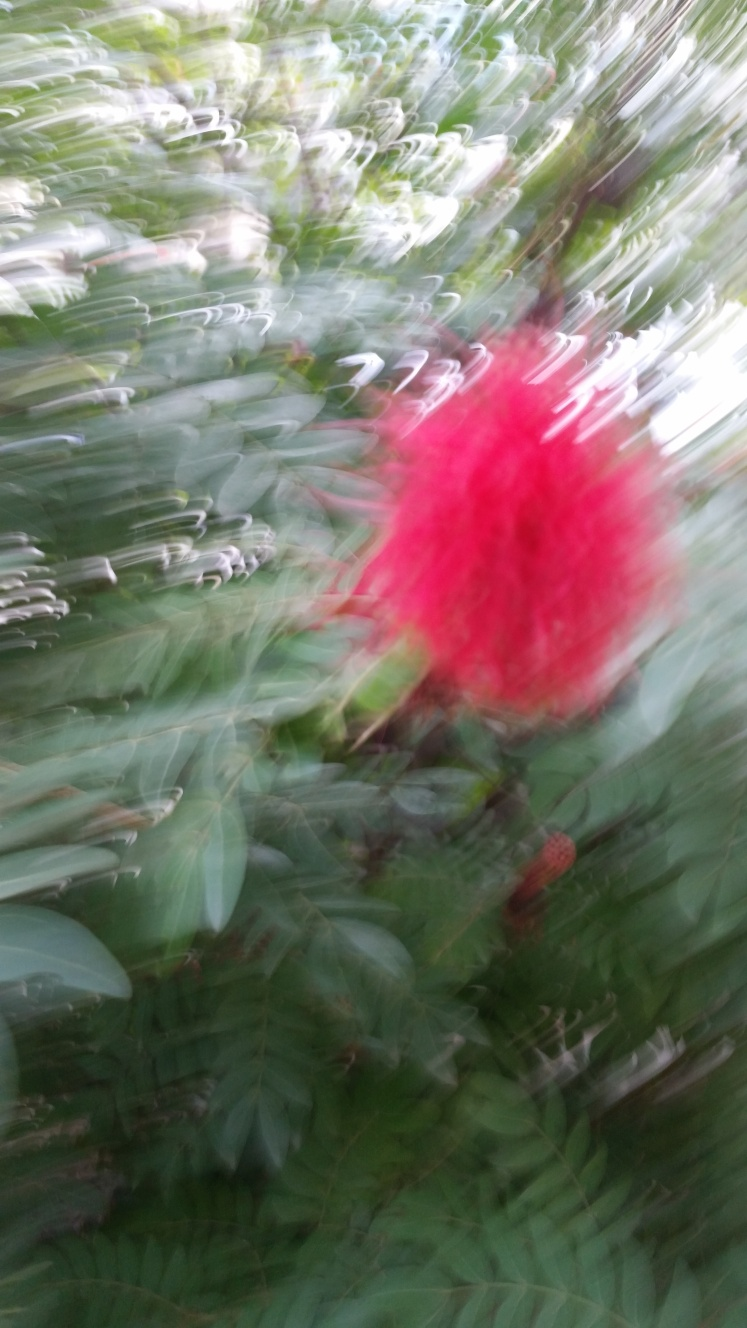What factors might have contributed to the image quality represented in this photo? Several factors could have affected the image quality. The most apparent is motion blur, which suggests either the camera shook or the subject moved during exposure. Additionally, improper focus settings or a low shutter speed under high motion conditions could contribute to this effect. Low lighting might have also necessitated a longer exposure, increasing the chance of blur. 